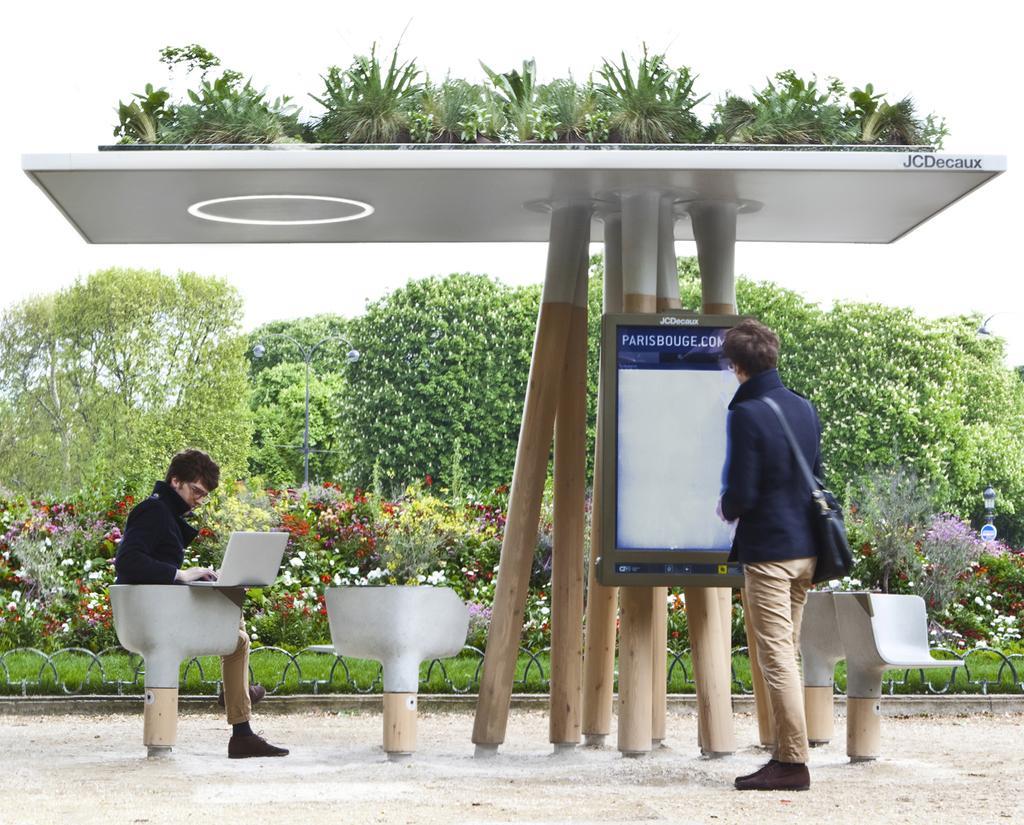How would you summarize this image in a sentence or two? In this picture, we see a man in the blue jacket is standing. He is wearing a bag. In front of him, we see a white board. Behind that, we see the wooden sticks. We see the flower pots are placed on the white plank. On the left side, we see a man is sitting on the cement chair and he is operating the laptop. In the background, we see the trees and plants. These plants have flowers and these flowers are in white, red, yellow and pink color. 